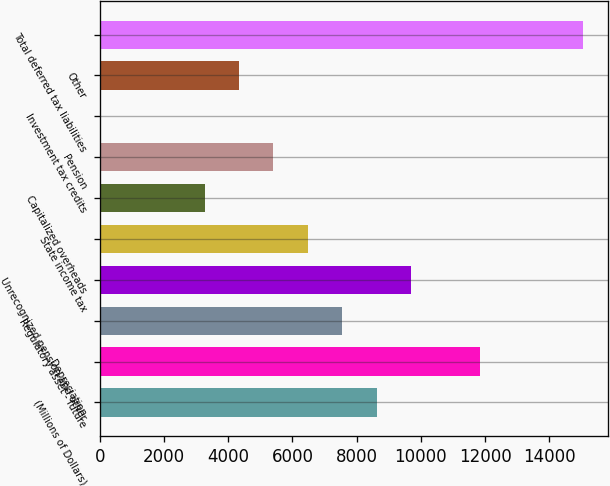Convert chart to OTSL. <chart><loc_0><loc_0><loc_500><loc_500><bar_chart><fcel>(Millions of Dollars)<fcel>Depreciation<fcel>Regulatory asset - future<fcel>Unrecognized pension and other<fcel>State income tax<fcel>Capitalized overheads<fcel>Pension<fcel>Investment tax credits<fcel>Other<fcel>Total deferred tax liabilities<nl><fcel>8626.2<fcel>11843.4<fcel>7553.8<fcel>9698.6<fcel>6481.4<fcel>3264.2<fcel>5409<fcel>47<fcel>4336.6<fcel>15060.6<nl></chart> 